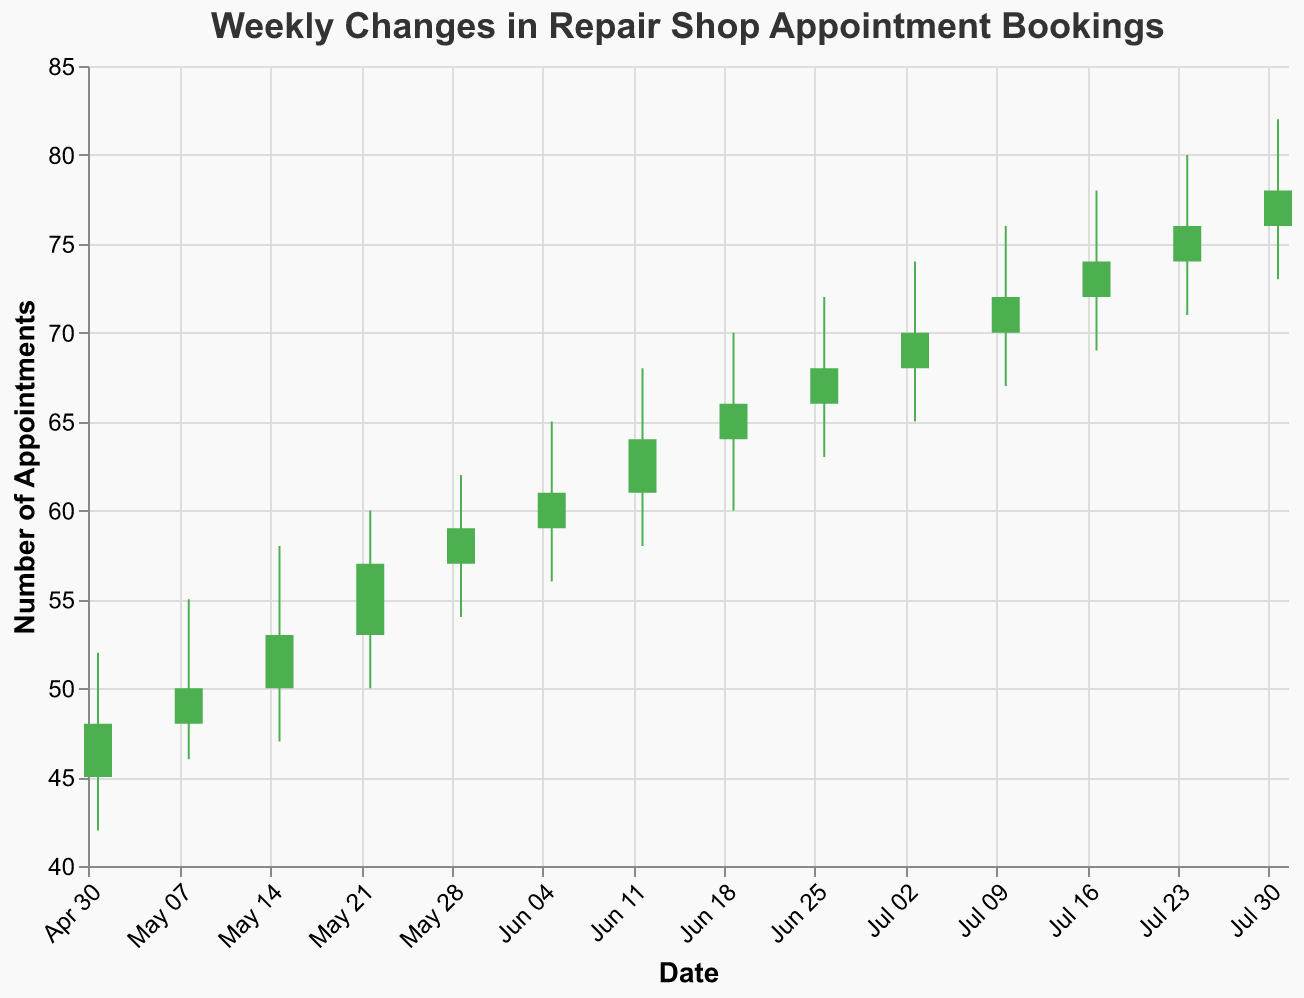What's the title of the figure? The title of the figure is displayed at the top and reads "Weekly Changes in Repair Shop Appointment Bookings".
Answer: Weekly Changes in Repair Shop Appointment Bookings What are the labels on the x-axis and y-axis? The x-axis is labeled "Date" and the y-axis is labeled "Number of Appointments". These labels can be seen along the axes at the bottom and left side of the chart, respectively.
Answer: Date, Number of Appointments How many weeks have increasing appointment bookings (green bars)? The green bars indicate weeks where the Close value is higher than the Open value. There are 13 weeks in total, and all weeks show green bars. This means every week had increasing appointment bookings.
Answer: 13 Which week had the highest number of appointments at close? By looking at the Close value across all weeks, the highest value is 78 on the week of 2023-07-31.
Answer: 2023-07-31 Which weeks had the smallest range between the High and Low values? The range is determined by subtracting the Low value from the High value. Comparing all weeks: Week of 2023-05-29 (62-54=8) and 2023-07-31 (82-73=9). The week of 2023-05-29 has the smallest range.
Answer: 2023-05-29 What's the difference between the Open and the Close values for the week of 2023-06-05? To find the difference, subtract the Open value from the Close value for that week: 61 - 59 = 2.
Answer: 2 Which week had the most significant drop in appointments within the week (i.e., highest value of High minus Lowest value)? The most significant drop occurs where the difference (High - Low) is maximum. The week of 2023-07-10 had values (76-67=9). The week of 2023-06-12 had values (68-58=10). The highest difference is seen during the week of 2023-06-12 with a 10 unit drop.
Answer: 2023-06-12 What's the average Close value for the month of July? The Close values for July (weeks of 2023-07-03, 2023-07-10, 2023-07-17, 2023-07-24, 2023-07-31) are 70, 72, 74, 76, 78. The sum is (70 + 72 + 74 + 76 + 78) = 370. The average is 370 / 5 = 74.
Answer: 74 